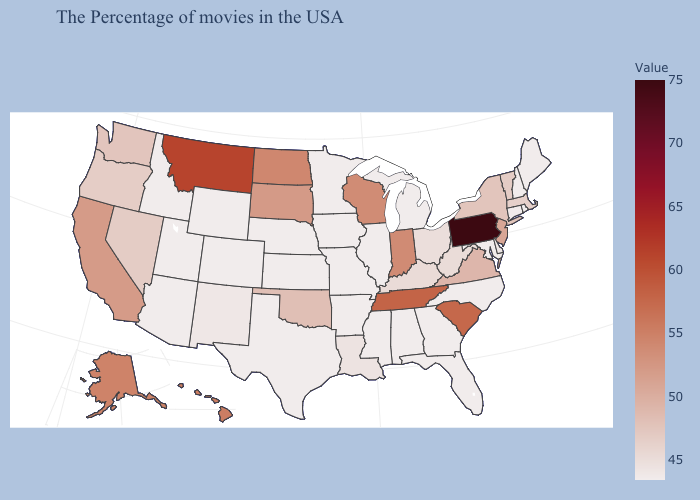Which states have the lowest value in the South?
Quick response, please. Maryland, North Carolina, Florida, Georgia, Alabama, Mississippi, Arkansas, Texas. Is the legend a continuous bar?
Keep it brief. Yes. Is the legend a continuous bar?
Answer briefly. Yes. Which states hav the highest value in the South?
Be succinct. Tennessee. Does Massachusetts have the lowest value in the USA?
Keep it brief. No. Does Wyoming have the highest value in the West?
Be succinct. No. Is the legend a continuous bar?
Quick response, please. Yes. 